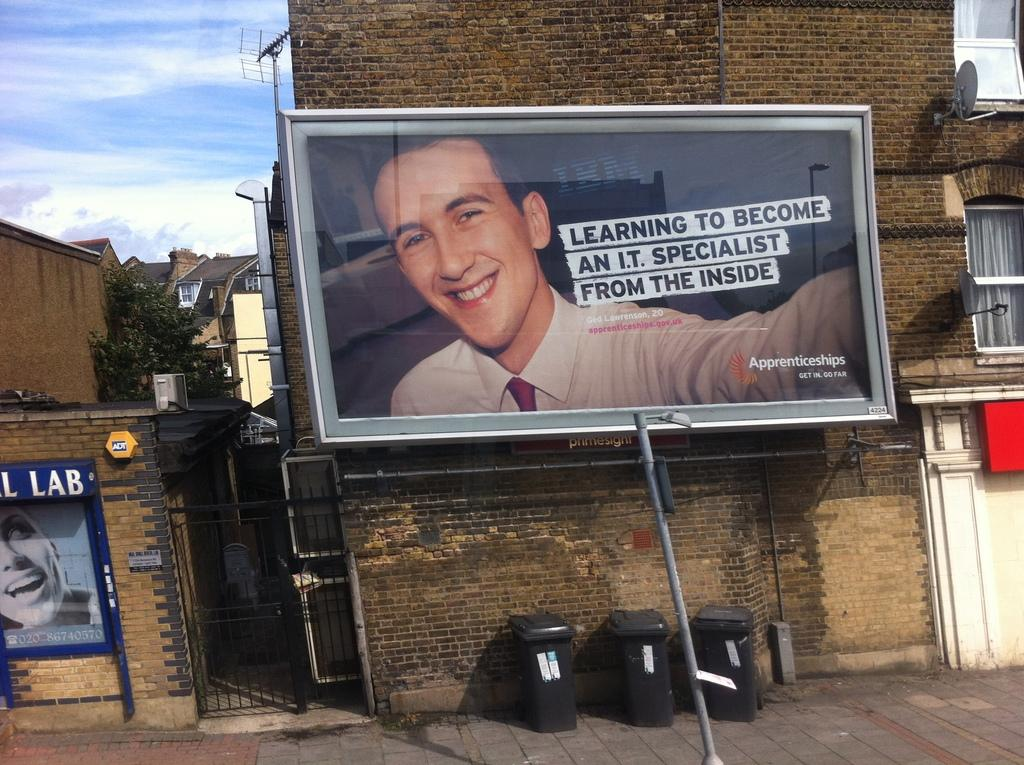<image>
Summarize the visual content of the image. a billboard of Apprenticeships on a brick wall 